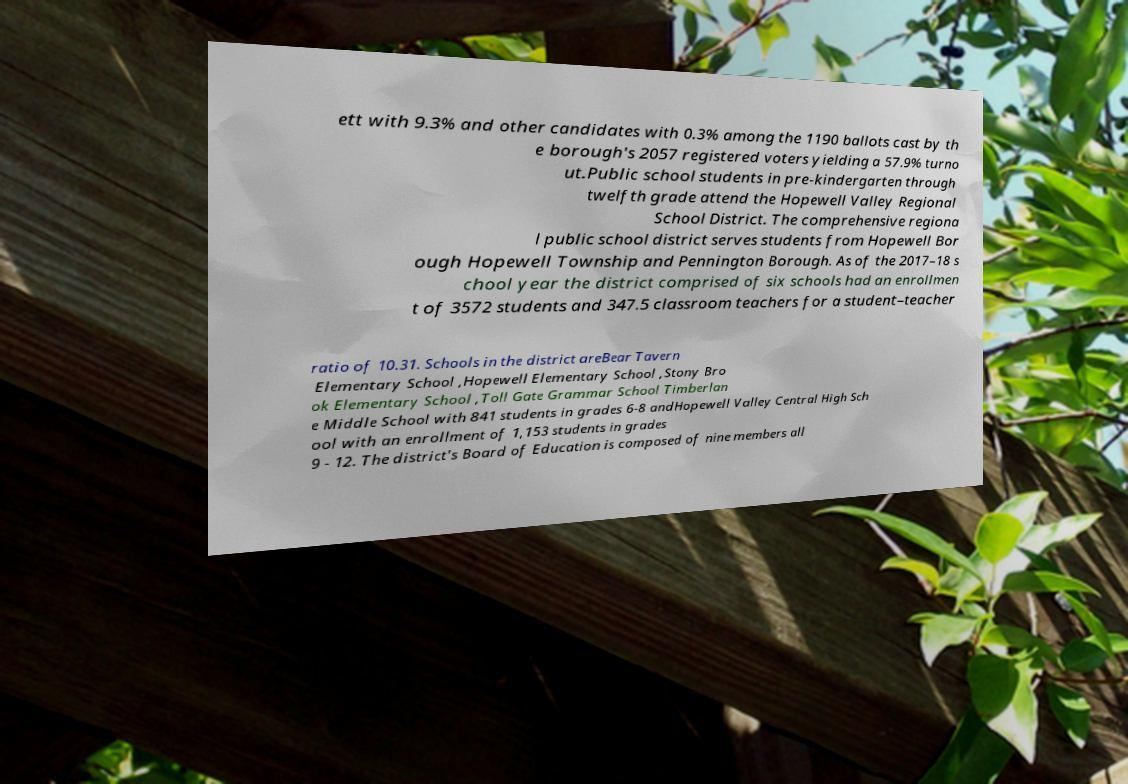There's text embedded in this image that I need extracted. Can you transcribe it verbatim? ett with 9.3% and other candidates with 0.3% among the 1190 ballots cast by th e borough's 2057 registered voters yielding a 57.9% turno ut.Public school students in pre-kindergarten through twelfth grade attend the Hopewell Valley Regional School District. The comprehensive regiona l public school district serves students from Hopewell Bor ough Hopewell Township and Pennington Borough. As of the 2017–18 s chool year the district comprised of six schools had an enrollmen t of 3572 students and 347.5 classroom teachers for a student–teacher ratio of 10.31. Schools in the district areBear Tavern Elementary School ,Hopewell Elementary School ,Stony Bro ok Elementary School ,Toll Gate Grammar School Timberlan e Middle School with 841 students in grades 6-8 andHopewell Valley Central High Sch ool with an enrollment of 1,153 students in grades 9 - 12. The district's Board of Education is composed of nine members all 